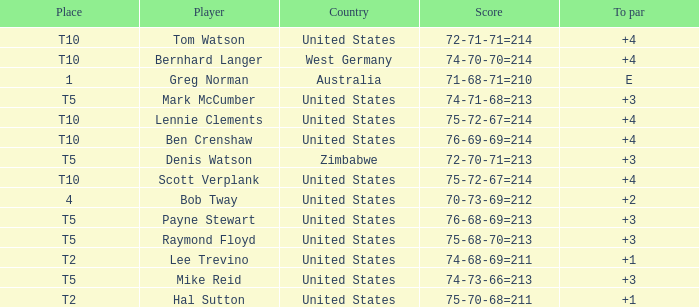Who is the player with a +3 to par and a 74-71-68=213 score? Mark McCumber. 